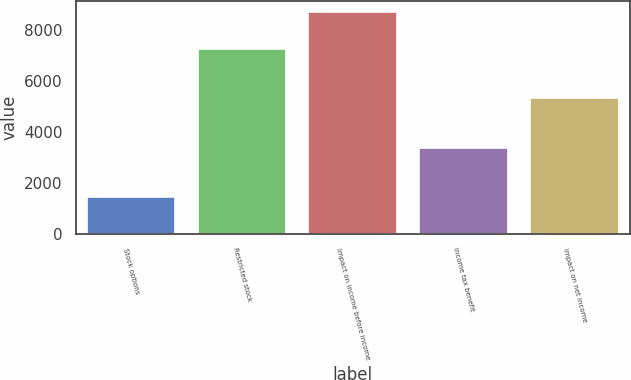Convert chart. <chart><loc_0><loc_0><loc_500><loc_500><bar_chart><fcel>Stock options<fcel>Restricted stock<fcel>Impact on income before income<fcel>Income tax benefit<fcel>Impact on net income<nl><fcel>1457<fcel>7238<fcel>8695<fcel>3382<fcel>5313<nl></chart> 